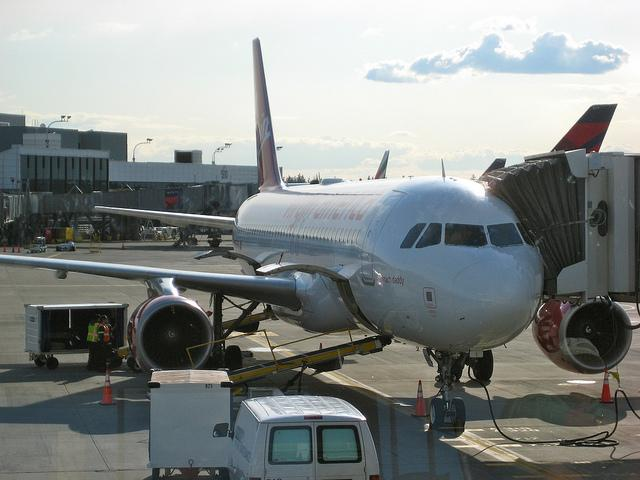Who created the first successful vehicle of this type? Please explain your reasoning. orville wright. Orville wright created the first plane. 